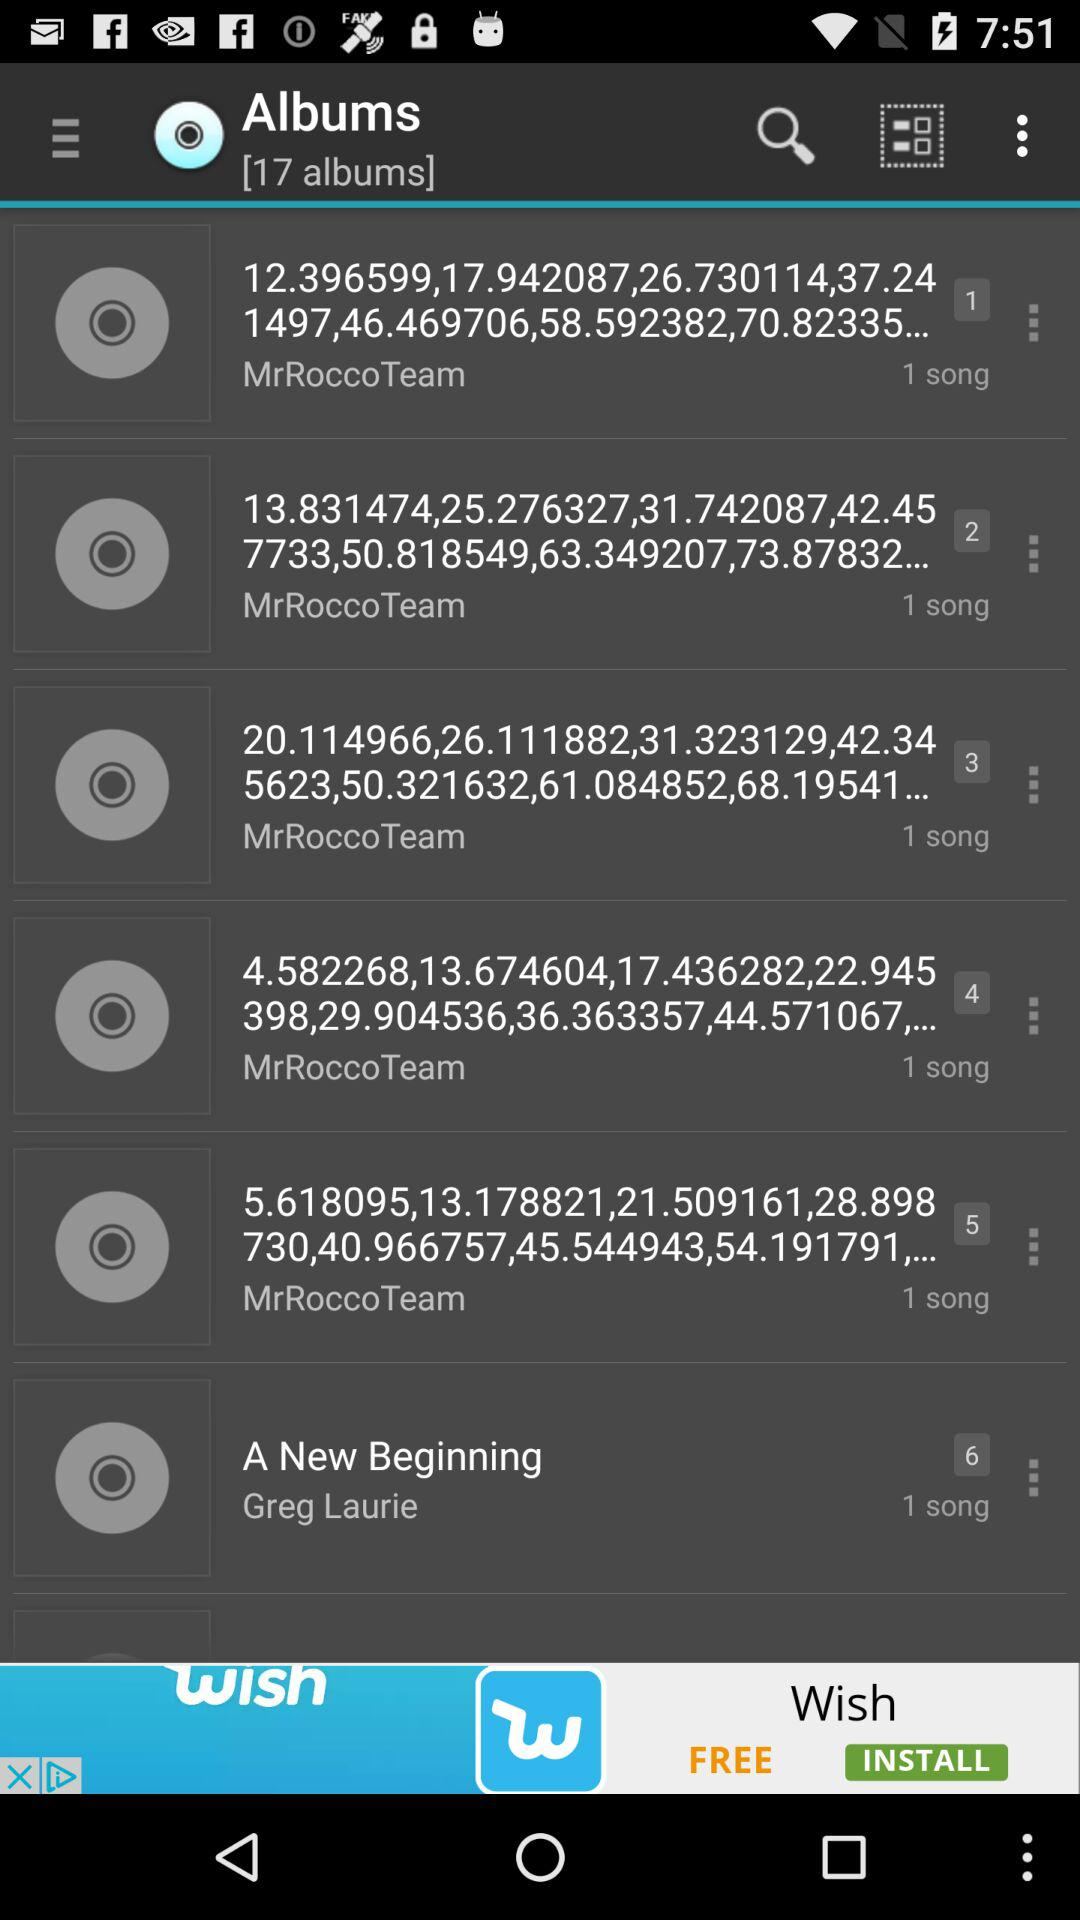How many songs are in the album 'A New Beginning'?
Answer the question using a single word or phrase. 1 